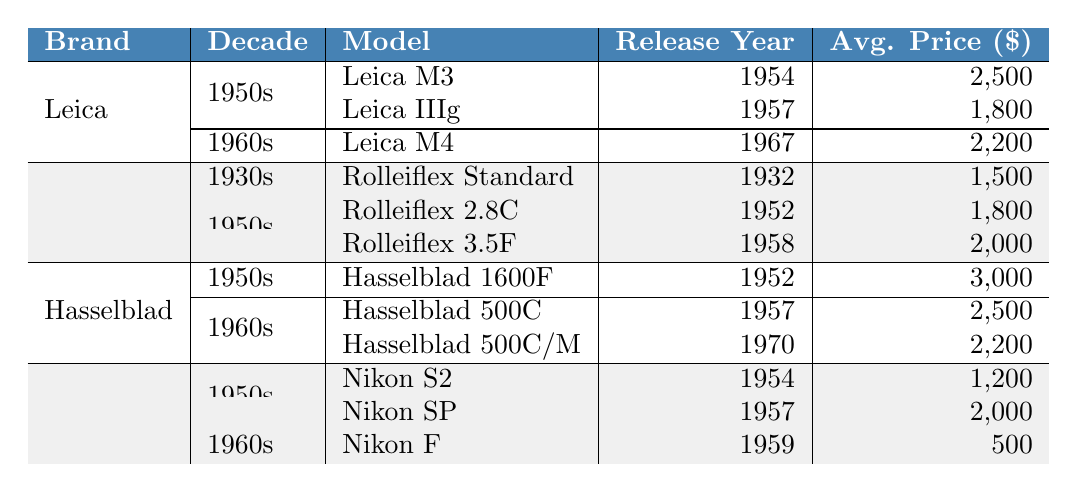What is the average price of the Leica M3? The average price listed for the Leica M3 in the table is $2500.
Answer: $2500 Which Rolleiflex model was released first? The table shows that the Rolleiflex Standard was released in 1932, which is earlier than any other Rolleiflex model listed.
Answer: Rolleiflex Standard What is the release year of the Nikon SP? According to the table, the Nikon SP was released in 1957.
Answer: 1957 Which brand has the highest recorded average price? Examining the average prices, Hasselblad 1600F has the highest price at $3000.
Answer: Hasselblad How many models did Leica release in the 1950s? Leica released two models in the 1950s: Leica M3 and Leica IIIg.
Answer: 2 What is the total average price of all Rolleiflex models listed in the table? The average prices for Rolleiflex models are $1500, $1800, and $2000. Summing them gives $1500 + $1800 + $2000 = $5300.
Answer: $5300 Is there a Nikon model released in the 1960s? Yes, there is one model listed in the 1960s: the Nikon F released in 1959.
Answer: Yes Which Hasselblad model has the lowest average price? Among the Hasselblad models listed, the Hasselblad 500C/M has the lowest average price of $2200.
Answer: Hasselblad 500C/M If you combine the average prices of all Nikon models, what is their total? The average prices for Nikon models are $1200, $2000, and $500, which sums to $1200 + $2000 + $500 = $3700.
Answer: $3700 What is the difference in average prices between the most expensive and least expensive Leica models? The most expensive Leica model is the Leica M3 ($2500) and the least expensive is the Leica IIIg ($1800). The difference is $2500 - $1800 = $700.
Answer: $700 